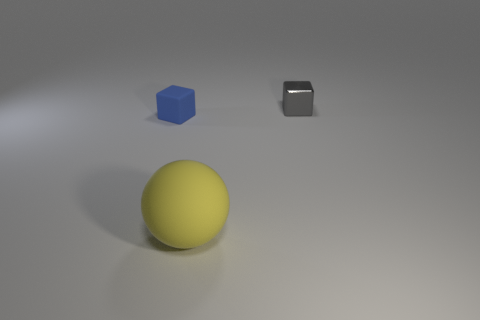Are there any other things that are the same size as the yellow matte ball?
Provide a short and direct response. No. Does the blue cube have the same material as the big yellow ball?
Your answer should be very brief. Yes. There is a cube on the right side of the tiny object left of the small gray object; what is its color?
Make the answer very short. Gray. What is the material of the gray thing that is the same size as the blue matte cube?
Ensure brevity in your answer.  Metal. There is a tiny object in front of the small thing to the right of the small thing that is to the left of the yellow matte ball; what color is it?
Provide a succinct answer. Blue. Is the shape of the tiny object to the left of the tiny gray block the same as the rubber thing on the right side of the blue object?
Keep it short and to the point. No. There is a rubber block that is the same size as the gray metal thing; what is its color?
Provide a succinct answer. Blue. Is the object in front of the blue matte block made of the same material as the object that is on the left side of the big rubber thing?
Ensure brevity in your answer.  Yes. There is a block left of the small cube to the right of the tiny blue matte block; what is its size?
Your answer should be compact. Small. What is the material of the blue thing that is in front of the tiny gray metal thing?
Your response must be concise. Rubber. 